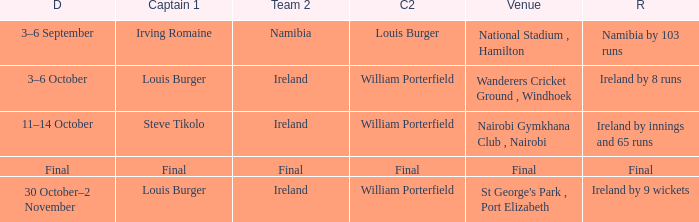Which Result has a Captain 1 of louis burger, and a Date of 30 october–2 november? Ireland by 9 wickets. Would you be able to parse every entry in this table? {'header': ['D', 'Captain 1', 'Team 2', 'C2', 'Venue', 'R'], 'rows': [['3–6 September', 'Irving Romaine', 'Namibia', 'Louis Burger', 'National Stadium , Hamilton', 'Namibia by 103 runs'], ['3–6 October', 'Louis Burger', 'Ireland', 'William Porterfield', 'Wanderers Cricket Ground , Windhoek', 'Ireland by 8 runs'], ['11–14 October', 'Steve Tikolo', 'Ireland', 'William Porterfield', 'Nairobi Gymkhana Club , Nairobi', 'Ireland by innings and 65 runs'], ['Final', 'Final', 'Final', 'Final', 'Final', 'Final'], ['30 October–2 November', 'Louis Burger', 'Ireland', 'William Porterfield', "St George's Park , Port Elizabeth", 'Ireland by 9 wickets']]} 